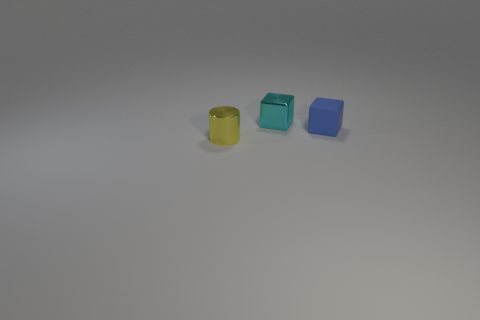The small yellow metallic thing is what shape?
Your response must be concise. Cylinder. Are there more metallic blocks that are in front of the small metal cylinder than tiny yellow shiny objects?
Keep it short and to the point. No. What number of things are cylinders in front of the small matte block or tiny objects that are behind the tiny yellow shiny object?
Keep it short and to the point. 3. The cyan block that is the same material as the tiny cylinder is what size?
Keep it short and to the point. Small. Do the tiny object on the right side of the tiny cyan thing and the yellow metallic thing have the same shape?
Offer a terse response. No. What number of blue things are tiny rubber cubes or cubes?
Provide a short and direct response. 1. How many other things are the same shape as the yellow object?
Provide a succinct answer. 0. There is a small object that is both on the left side of the rubber thing and on the right side of the tiny yellow shiny cylinder; what is its shape?
Offer a very short reply. Cube. Are there any tiny cyan shiny cubes on the right side of the cyan metal cube?
Your answer should be very brief. No. What is the size of the other object that is the same shape as the cyan metal object?
Your answer should be very brief. Small. 